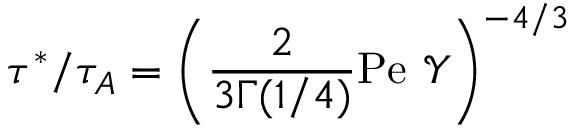Convert formula to latex. <formula><loc_0><loc_0><loc_500><loc_500>\tau ^ { * } / \tau _ { A } = \left ( \frac { 2 } { 3 \Gamma ( 1 / 4 ) } P e \ \mathcal { Y } \right ) ^ { - 4 / 3 }</formula> 